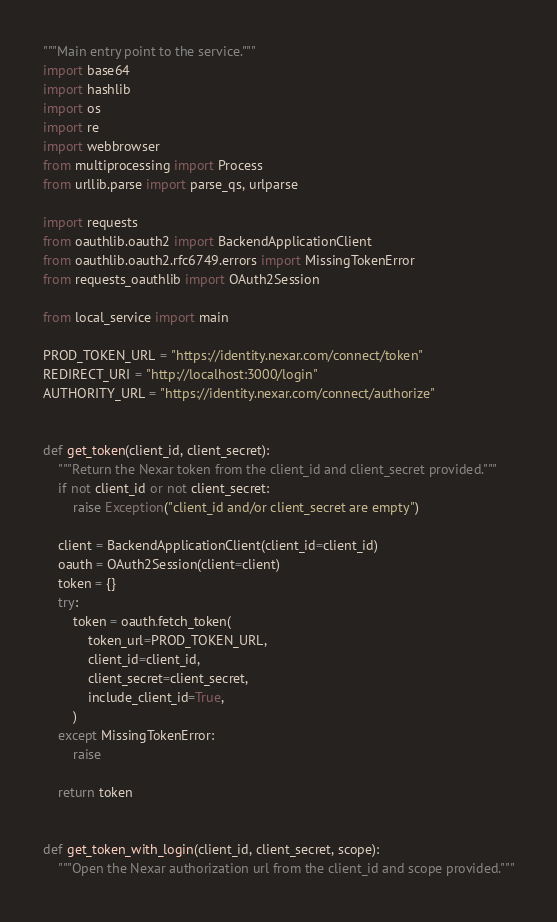Convert code to text. <code><loc_0><loc_0><loc_500><loc_500><_Python_>"""Main entry point to the service."""
import base64
import hashlib
import os
import re
import webbrowser
from multiprocessing import Process
from urllib.parse import parse_qs, urlparse

import requests
from oauthlib.oauth2 import BackendApplicationClient
from oauthlib.oauth2.rfc6749.errors import MissingTokenError
from requests_oauthlib import OAuth2Session

from local_service import main

PROD_TOKEN_URL = "https://identity.nexar.com/connect/token"
REDIRECT_URI = "http://localhost:3000/login"
AUTHORITY_URL = "https://identity.nexar.com/connect/authorize"


def get_token(client_id, client_secret):
    """Return the Nexar token from the client_id and client_secret provided."""
    if not client_id or not client_secret:
        raise Exception("client_id and/or client_secret are empty")

    client = BackendApplicationClient(client_id=client_id)
    oauth = OAuth2Session(client=client)
    token = {}
    try:
        token = oauth.fetch_token(
            token_url=PROD_TOKEN_URL,
            client_id=client_id,
            client_secret=client_secret,
            include_client_id=True,
        )
    except MissingTokenError:
        raise

    return token


def get_token_with_login(client_id, client_secret, scope):
    """Open the Nexar authorization url from the client_id and scope provided."""</code> 